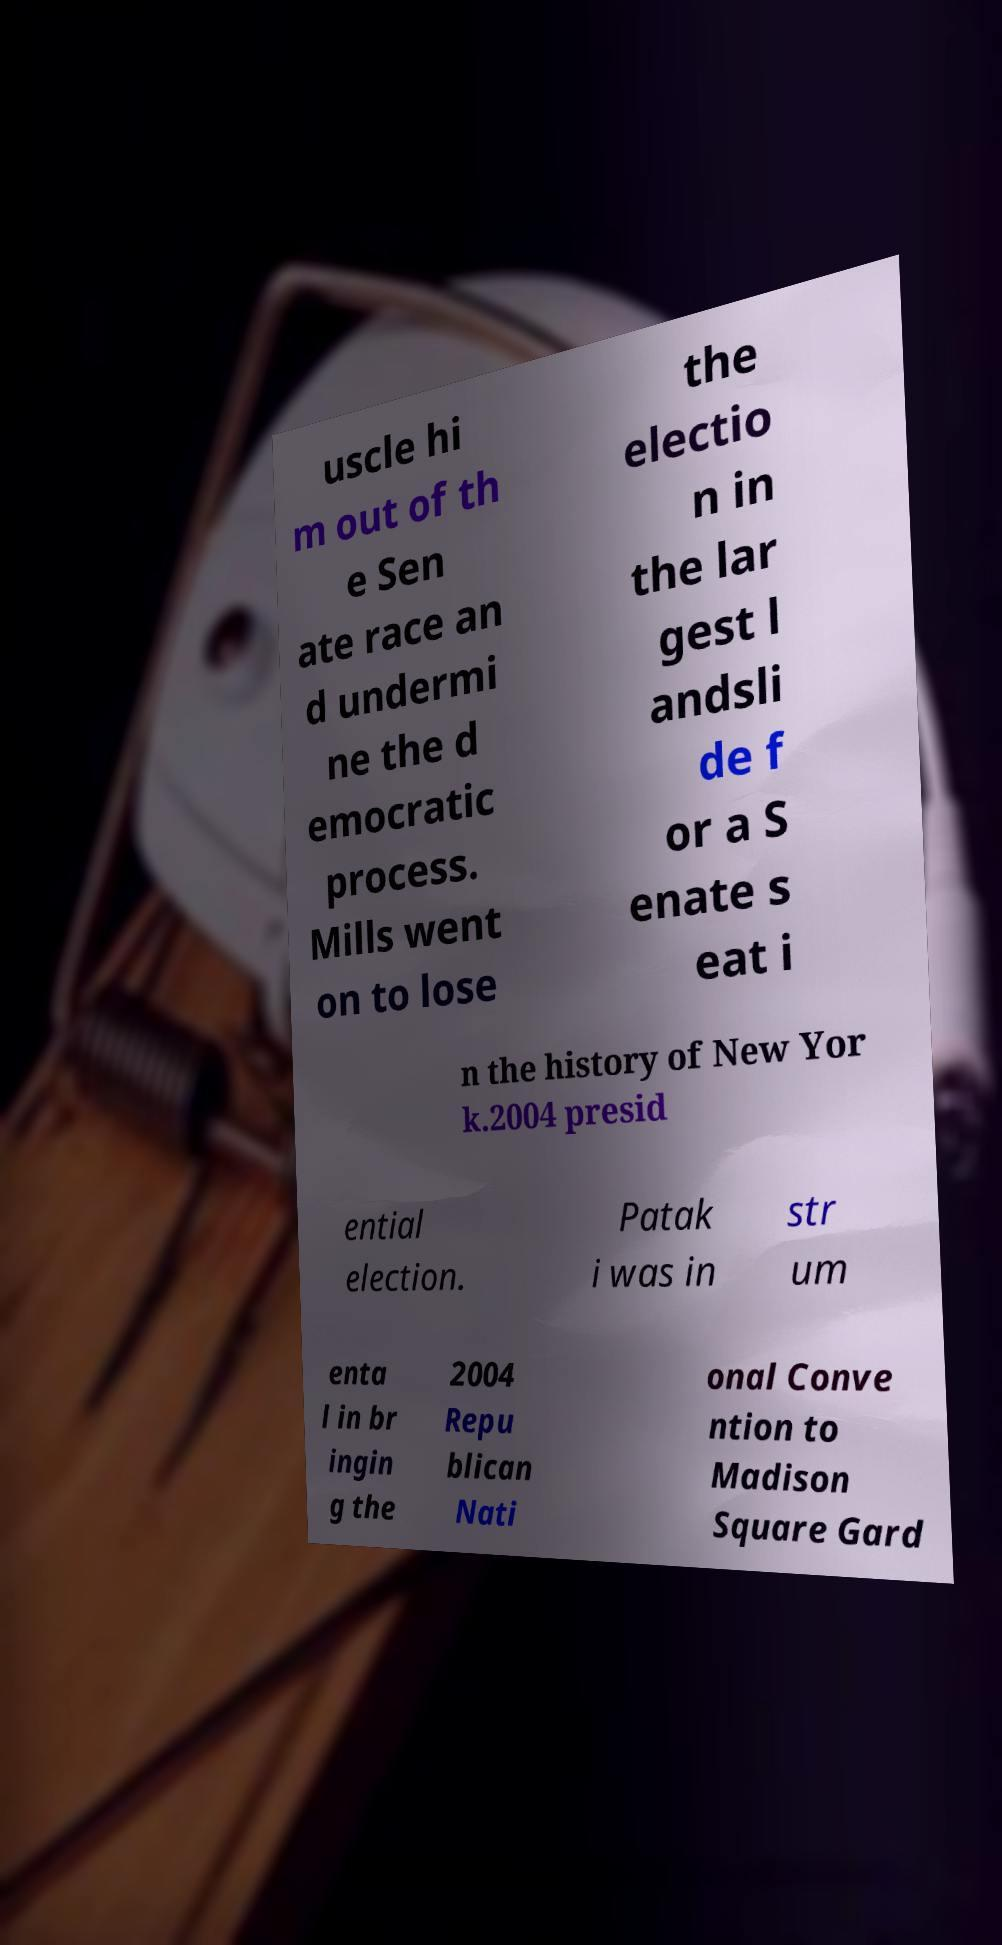For documentation purposes, I need the text within this image transcribed. Could you provide that? uscle hi m out of th e Sen ate race an d undermi ne the d emocratic process. Mills went on to lose the electio n in the lar gest l andsli de f or a S enate s eat i n the history of New Yor k.2004 presid ential election. Patak i was in str um enta l in br ingin g the 2004 Repu blican Nati onal Conve ntion to Madison Square Gard 